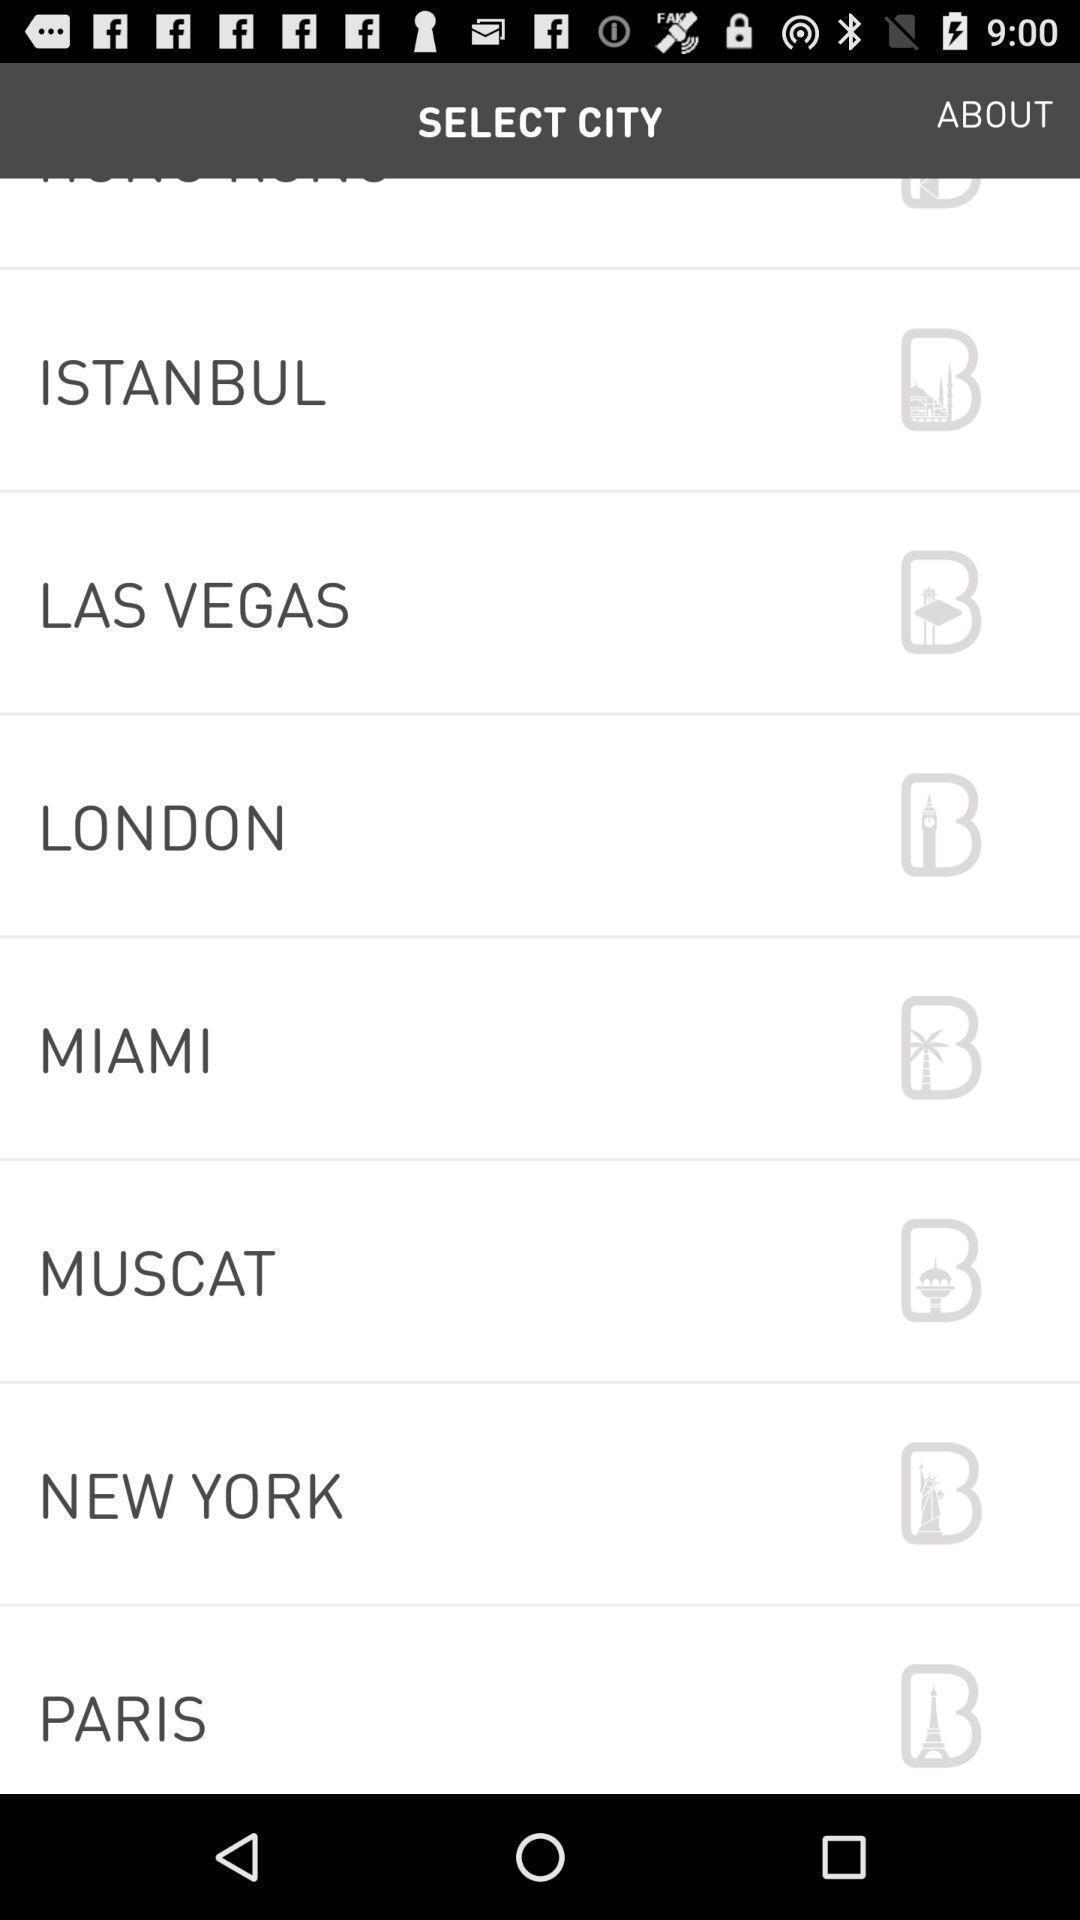Tell me what you see in this picture. Screen showing list of various cities. 